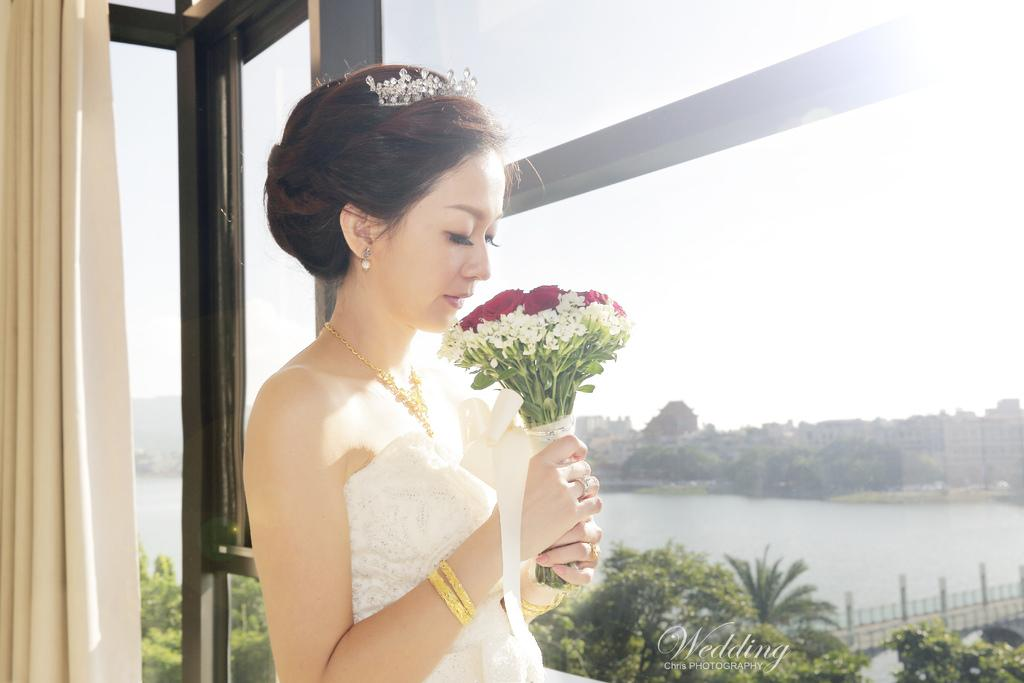Who is present in the image? There is a woman in the image. What is the woman holding? The woman is holding a flower bouquet. What can be seen in the background of the image? There are buildings, trees, a fence, and the sky visible in the background of the image. Can you describe any architectural features in the image? Yes, there is a curtain in the image. How many balls are visible in the image? There are no balls present in the image. What type of needle is being used by the woman in the image? There is no needle present in the image; the woman is holding a flower bouquet. 